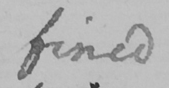Can you tell me what this handwritten text says? fined 